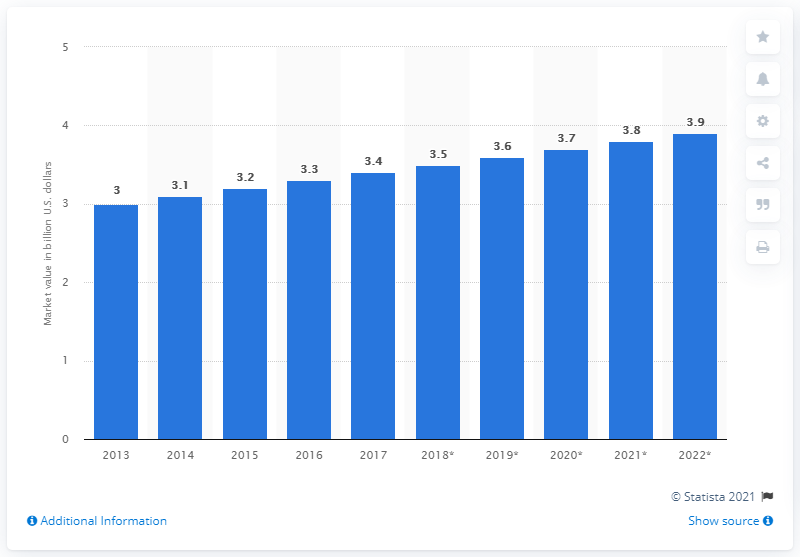Draw attention to some important aspects in this diagram. The forecast value of the Canadian confectionery market in 2022 was 3.9 billion dollars. 